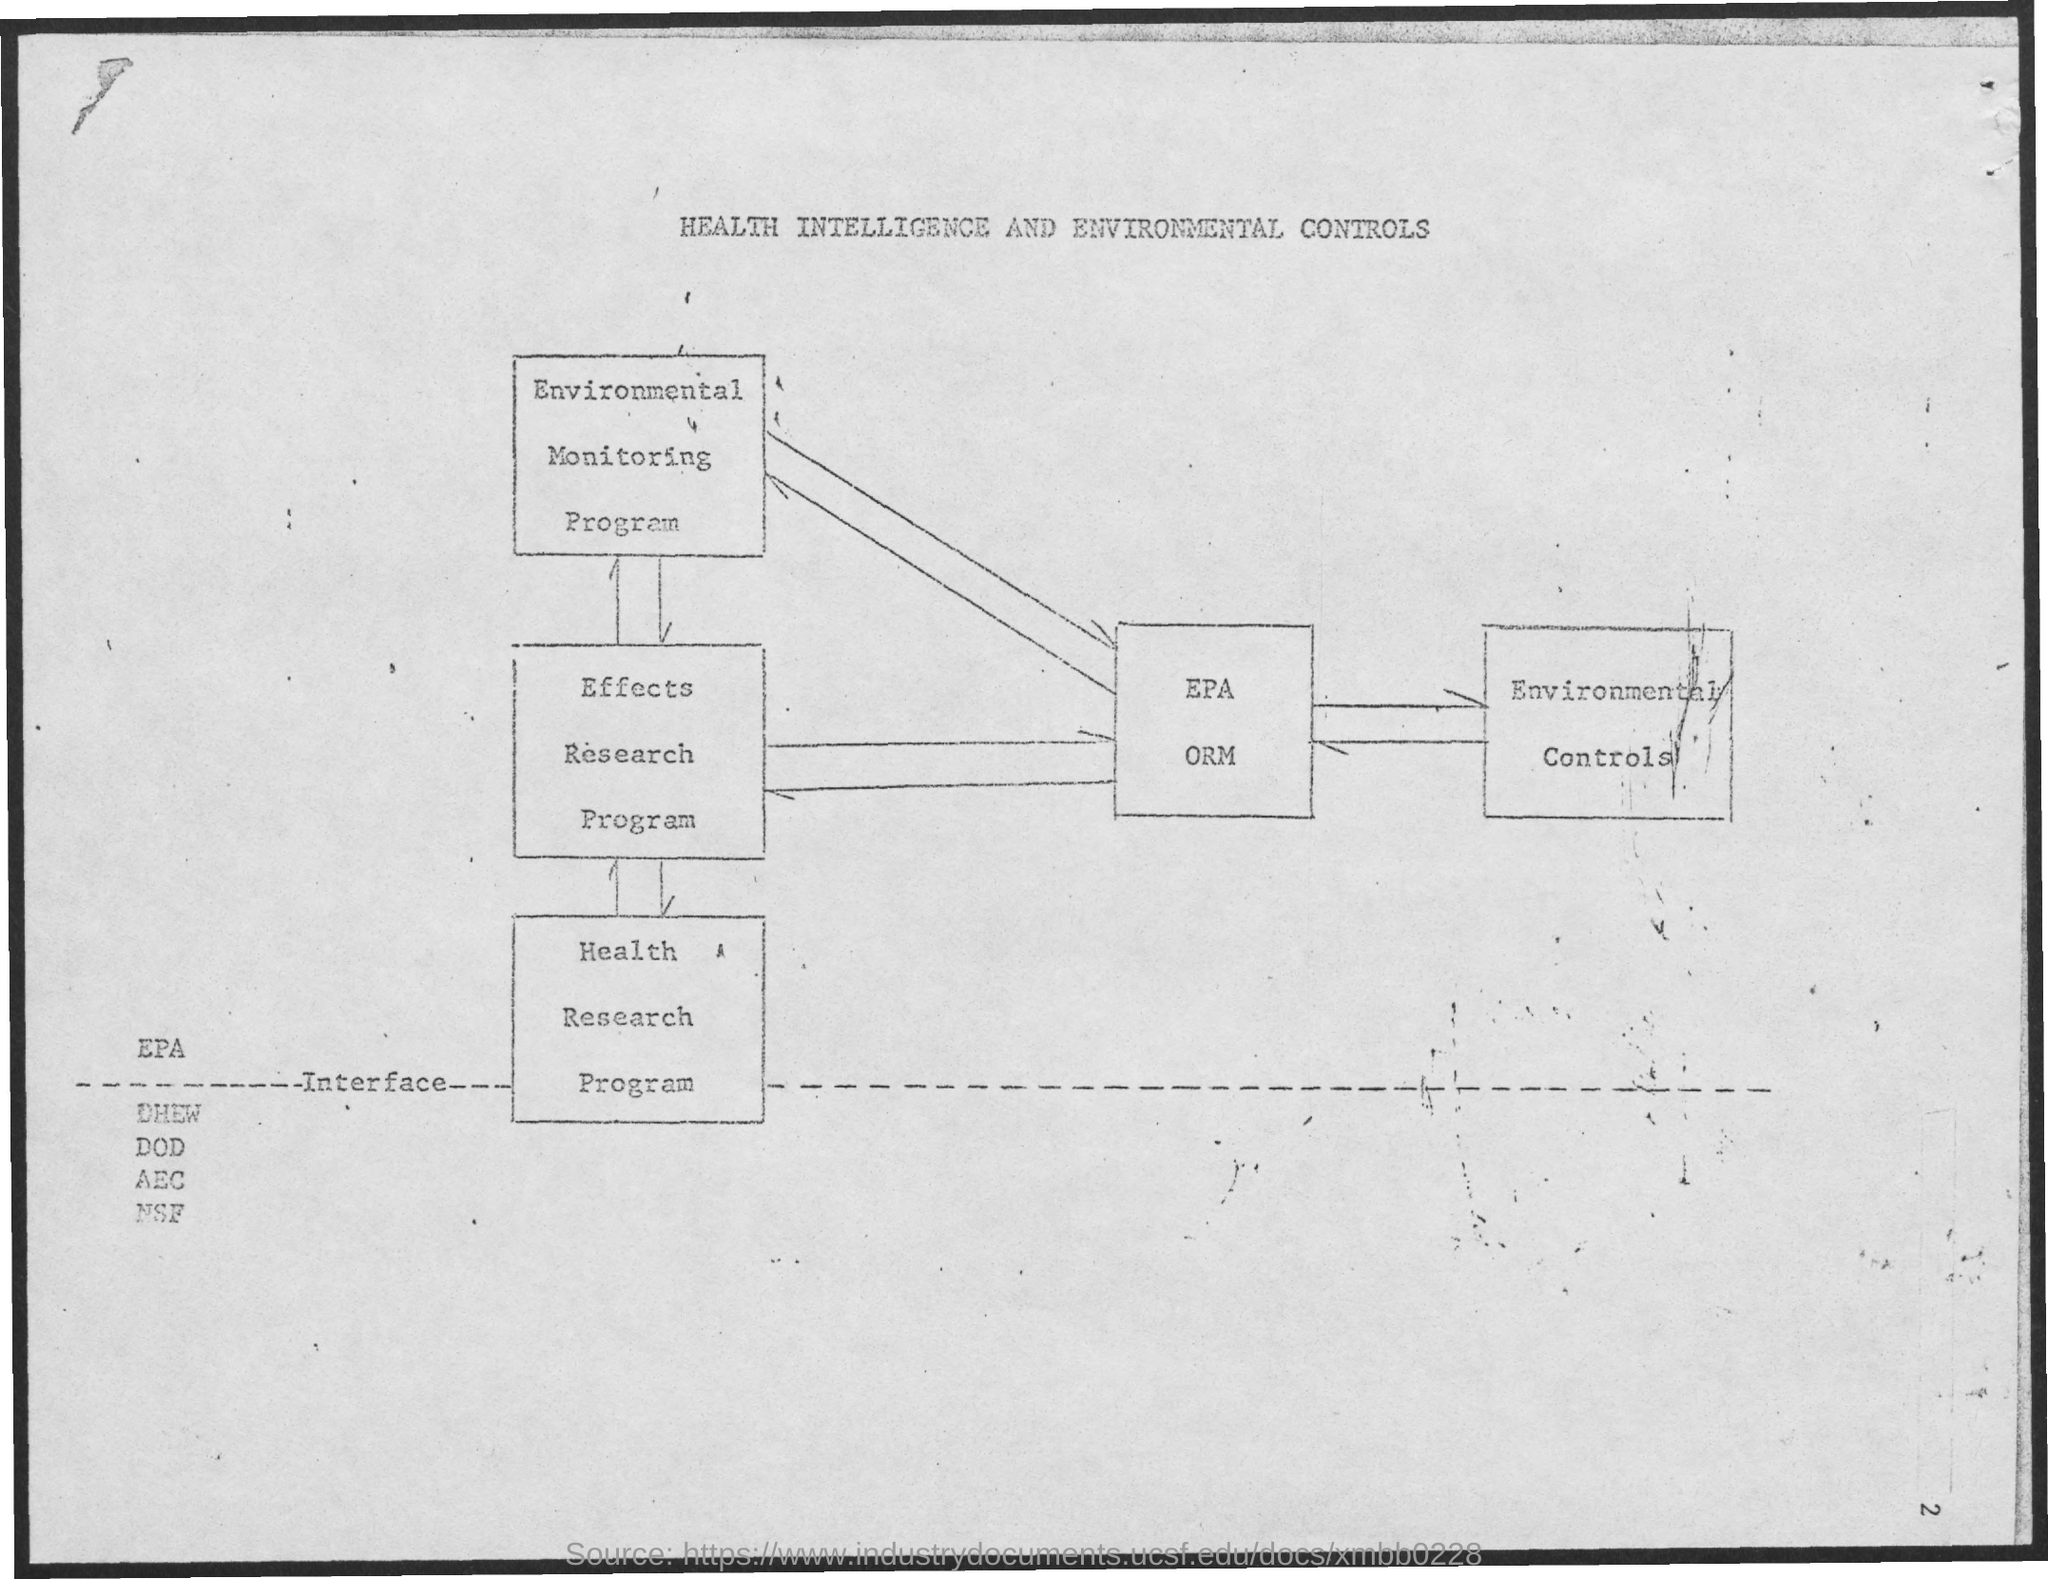Mention a couple of crucial points in this snapshot. The title of the document is 'Health Intelligence and Environmental Controls.' 